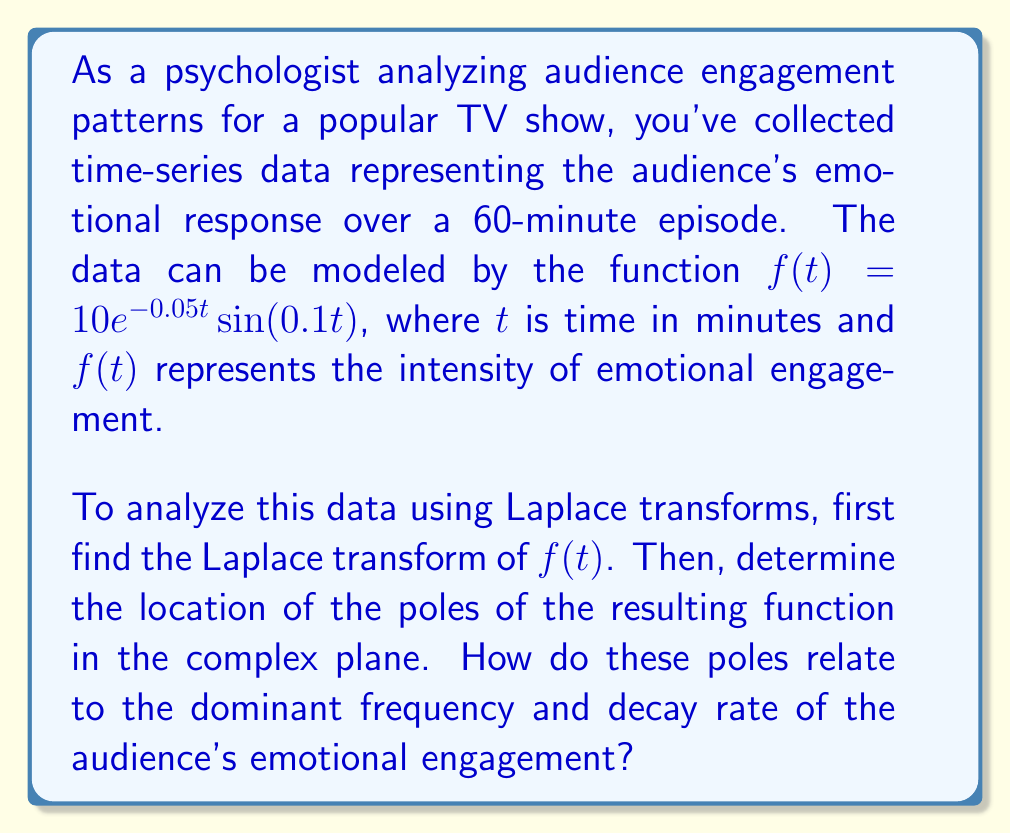Help me with this question. Let's approach this step-by-step:

1) The Laplace transform of $f(t) = 10e^{-0.05t}\sin(0.1t)$ is given by:

   $$\mathcal{L}\{f(t)\} = \int_0^\infty 10e^{-0.05t}\sin(0.1t)e^{-st}dt$$

2) We can use the known Laplace transform of $e^{at}\sin(bt)$:

   $$\mathcal{L}\{e^{at}\sin(bt)\} = \frac{b}{(s-a)^2 + b^2}$$

3) In our case, $a = -0.05$ and $b = 0.1$. Also, we have a factor of 10. So:

   $$\mathcal{L}\{f(t)\} = \frac{10 \cdot 0.1}{(s+0.05)^2 + 0.1^2} = \frac{1}{(s+0.05)^2 + 0.1^2}$$

4) To find the poles, we need to find the values of $s$ that make the denominator zero:

   $$(s+0.05)^2 + 0.1^2 = 0$$
   $$(s+0.05)^2 = -0.1^2 = -0.01$$
   $$s+0.05 = \pm 0.1i$$
   $$s = -0.05 \pm 0.1i$$

5) So the poles are located at $s = -0.05 + 0.1i$ and $s = -0.05 - 0.1i$ in the complex plane.

6) The real part of the poles (-0.05) corresponds to the decay rate of the emotional engagement. A negative value indicates that the engagement decays over time.

7) The imaginary part of the poles (±0.1) corresponds to the frequency of oscillation in the emotional engagement. This matches the frequency in the original function $\sin(0.1t)$.

These poles provide important insights into the audience's emotional engagement:
- The decay rate of 0.05 suggests how quickly the intensity of emotional engagement diminishes over time.
- The frequency of 0.1 indicates how rapidly the emotional engagement oscillates between positive and negative responses.

As a psychologist, you could interpret this as the audience experiencing regular emotional peaks and troughs throughout the episode, with an overall gradual decrease in intensity as the episode progresses.
Answer: The Laplace transform of $f(t)$ is $F(s) = \frac{1}{(s+0.05)^2 + 0.1^2}$. The poles are located at $s = -0.05 \pm 0.1i$ in the complex plane. The real part (-0.05) represents the decay rate of emotional engagement, while the imaginary part (±0.1) corresponds to the frequency of oscillation in emotional response, matching the original function's frequency. 